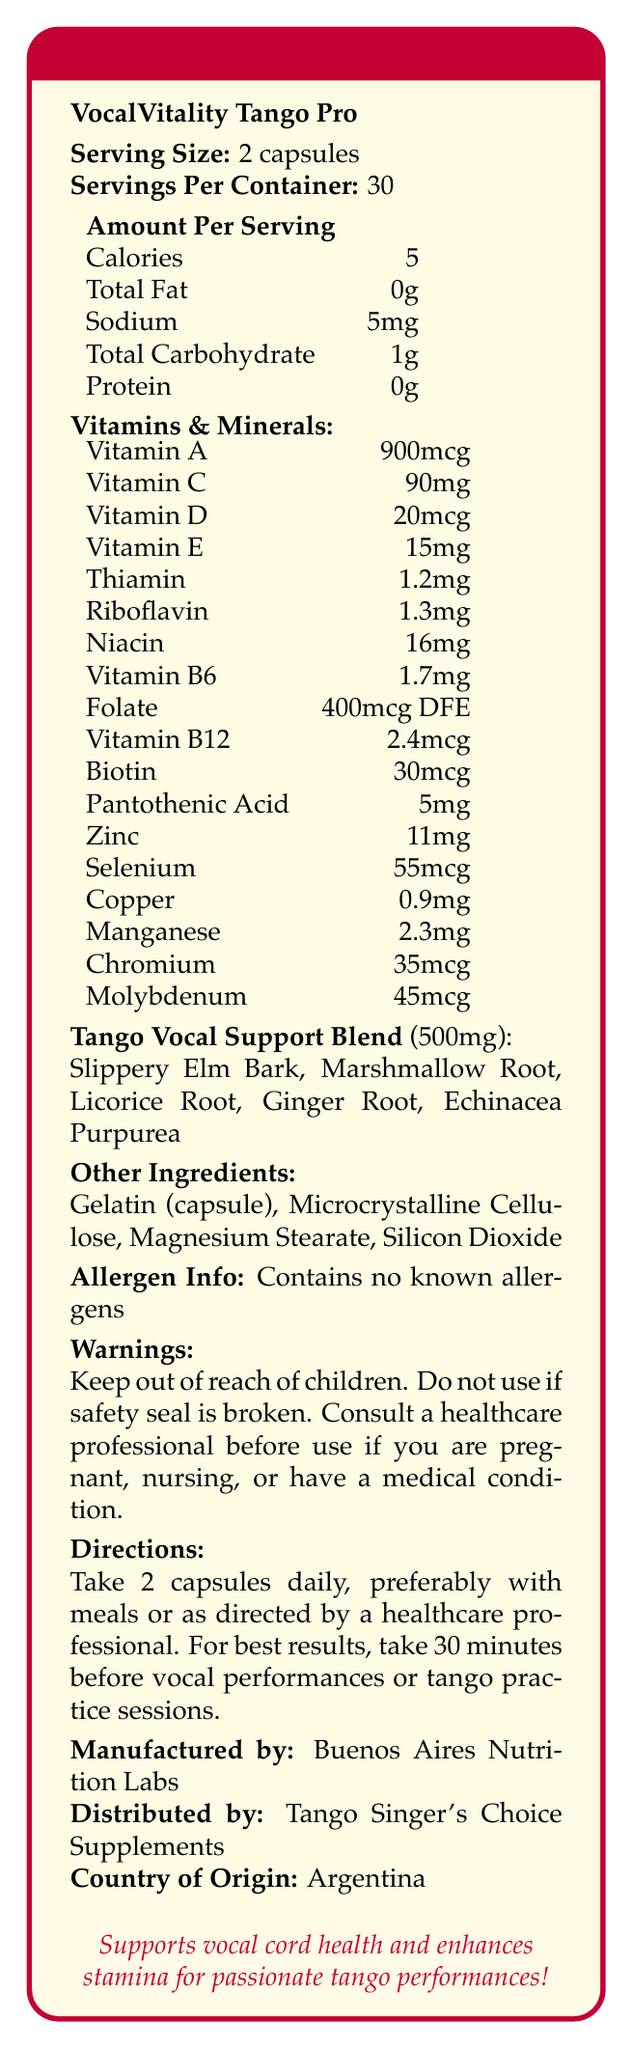what is the product name? The product name is clearly stated at the beginning of the nutrition facts label.
Answer: VocalVitality Tango Pro how many capsules are in one serving? The serving size is explicitly mentioned as "2 capsules."
Answer: 2 capsules how many calories are in a serving? According to the label, each serving contains 5 calories.
Answer: 5 calories how many servings are there in one container? The document states that there are 30 servings per container.
Answer: 30 servings what are the main vitamins included in the supplement? This is a list of all the vitamins mentioned under the "Vitamins & Minerals" section.
Answer: Vitamin A, Vitamin C, Vitamin D, Vitamin E, Thiamin, Riboflavin, Niacin, Vitamin B6, Folate, Vitamin B12, Biotin, Pantothenic Acid which ingredient is not part of the Tango Vocal Support Blend? A. Ginger Root B. Echinacea Purpurea C. Microcrystalline Cellulose D. Licorice Root Microcrystalline Cellulose is listed under "Other Ingredients," not as part of the Tango Vocal Support Blend.
Answer: C. Microcrystalline Cellulose how much Vitamin B12 is in a serving? The label indicates that each serving contains 2.4mcg of Vitamin B12.
Answer: 2.4mcg does the supplement contain any known allergens? The allergen information section indicates that the product contains no known allergens.
Answer: No what is one of the marketing claims made about the supplement? This is one of the marketing claims listed towards the end of the document.
Answer: Supports vocal cord health and resilience how should the supplement be taken for best results? A. 2 capsules with meals B. 2 capsules before bed C. 2 capsules 30 minutes before vocal performances D. 2 capsules while drinking water The directions suggest taking the supplement 30 minutes before vocal performances or tango practice sessions for best results.
Answer: C. 2 capsules 30 minutes before vocal performances is the supplement suitable for pregnant women without consultation? The warnings section advises consulting a healthcare professional before use if you are pregnant, nursing, or have a medical condition.
Answer: No summarize the main focus of this nutrition facts label in one or two sentences. The label provides comprehensive information on the supplement's nutritional contents, intended to enhance vocal and performance abilities, particularly for tango singers.
Answer: The nutrition facts label details the ingredients and nutritional content of VocalVitality Tango Pro, a vitamin supplement designed to support vocal health and performance stamina for tango singers, with information on serving size, vitamins, proprietary blend, and usage directions. where is the supplement manufactured? The label specifies that the supplement is manufactured by Buenos Aires Nutrition Labs in Argentina.
Answer: Argentina how many mg of Zinc are in a serving? The document states that each serving contains 11mg of Zinc.
Answer: 11mg identify an ingredient found in the “other ingredients” list. Gelatin (capsule) is explicitly mentioned under "Other Ingredients."
Answer: Gelatin (capsule) what is the proprietary blend called? The proprietary blend is named Tango Vocal Support Blend.
Answer: Tango Vocal Support Blend what is the role of Silicon Dioxide in the supplement? The document lists Silicon Dioxide among the other ingredients but doesn't specify its role.
Answer: Cannot be determined 